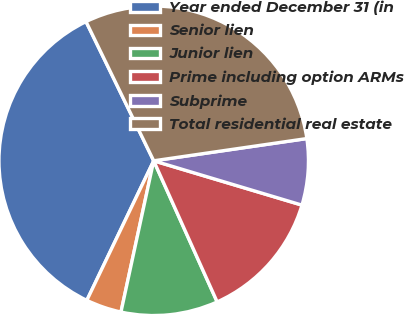Convert chart. <chart><loc_0><loc_0><loc_500><loc_500><pie_chart><fcel>Year ended December 31 (in<fcel>Senior lien<fcel>Junior lien<fcel>Prime including option ARMs<fcel>Subprime<fcel>Total residential real estate<nl><fcel>35.69%<fcel>3.72%<fcel>10.12%<fcel>13.65%<fcel>6.92%<fcel>29.91%<nl></chart> 